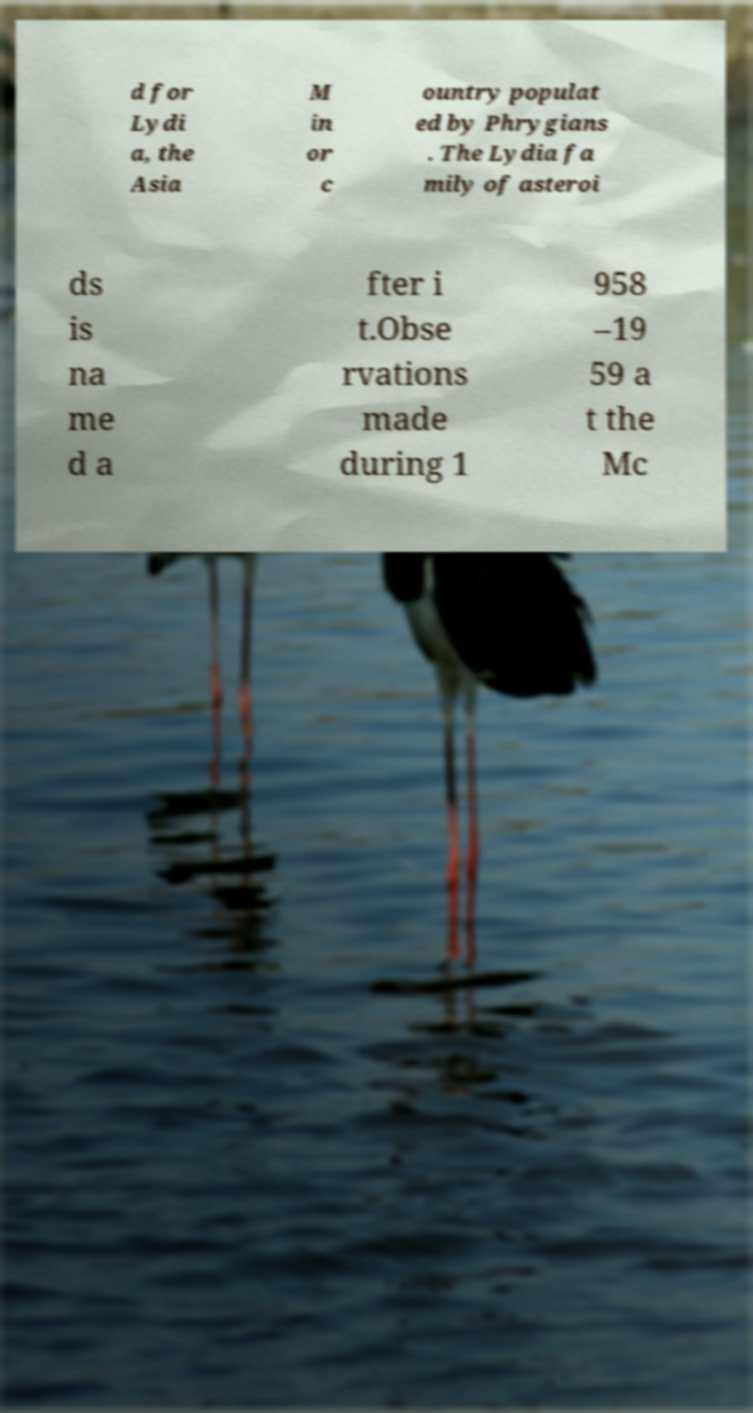Could you assist in decoding the text presented in this image and type it out clearly? d for Lydi a, the Asia M in or c ountry populat ed by Phrygians . The Lydia fa mily of asteroi ds is na me d a fter i t.Obse rvations made during 1 958 –19 59 a t the Mc 